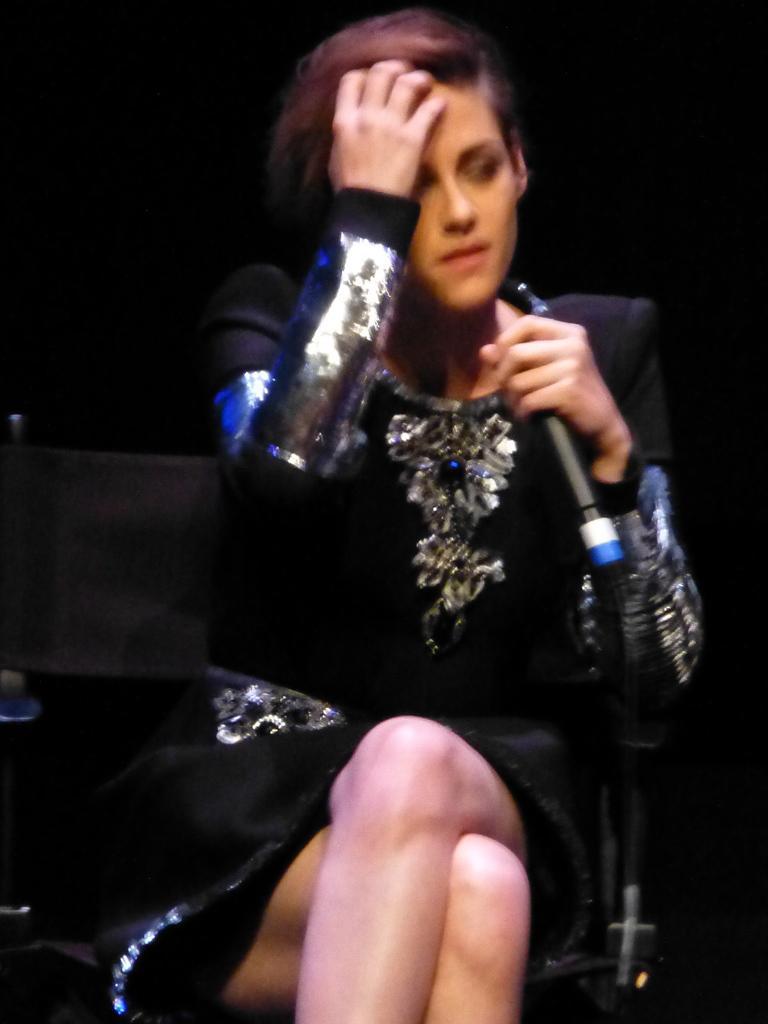How would you summarize this image in a sentence or two? In this picture there is a woman sitting on a chair and holding a microphone. In the background of the image it is dark. 